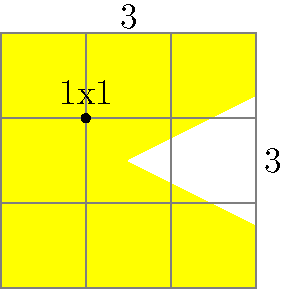As a pixel artist, you're working on a retro game character inspired by Pac-Man. The character is composed of 3x3 square pixels, with a triangular mouth cut out and a 1x1 pixel eye. What is the total area of the character in square pixels? Let's approach this step-by-step:

1. First, calculate the area of the full 3x3 square:
   Area of square = $3 \times 3 = 9$ square pixels

2. Next, determine the area of the triangular mouth:
   The mouth forms a right triangle with base and height of 2 pixels.
   Area of triangle = $\frac{1}{2} \times base \times height = \frac{1}{2} \times 2 \times 2 = 2$ square pixels

3. The eye occupies 1 square pixel.

4. Calculate the total area of the character:
   Total area = Area of square - Area of mouth - Area of eye
               = $9 - 2 - 1 = 6$ square pixels

Therefore, the total area of the Pac-Man inspired character is 6 square pixels.
Answer: 6 square pixels 